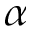Convert formula to latex. <formula><loc_0><loc_0><loc_500><loc_500>\alpha</formula> 